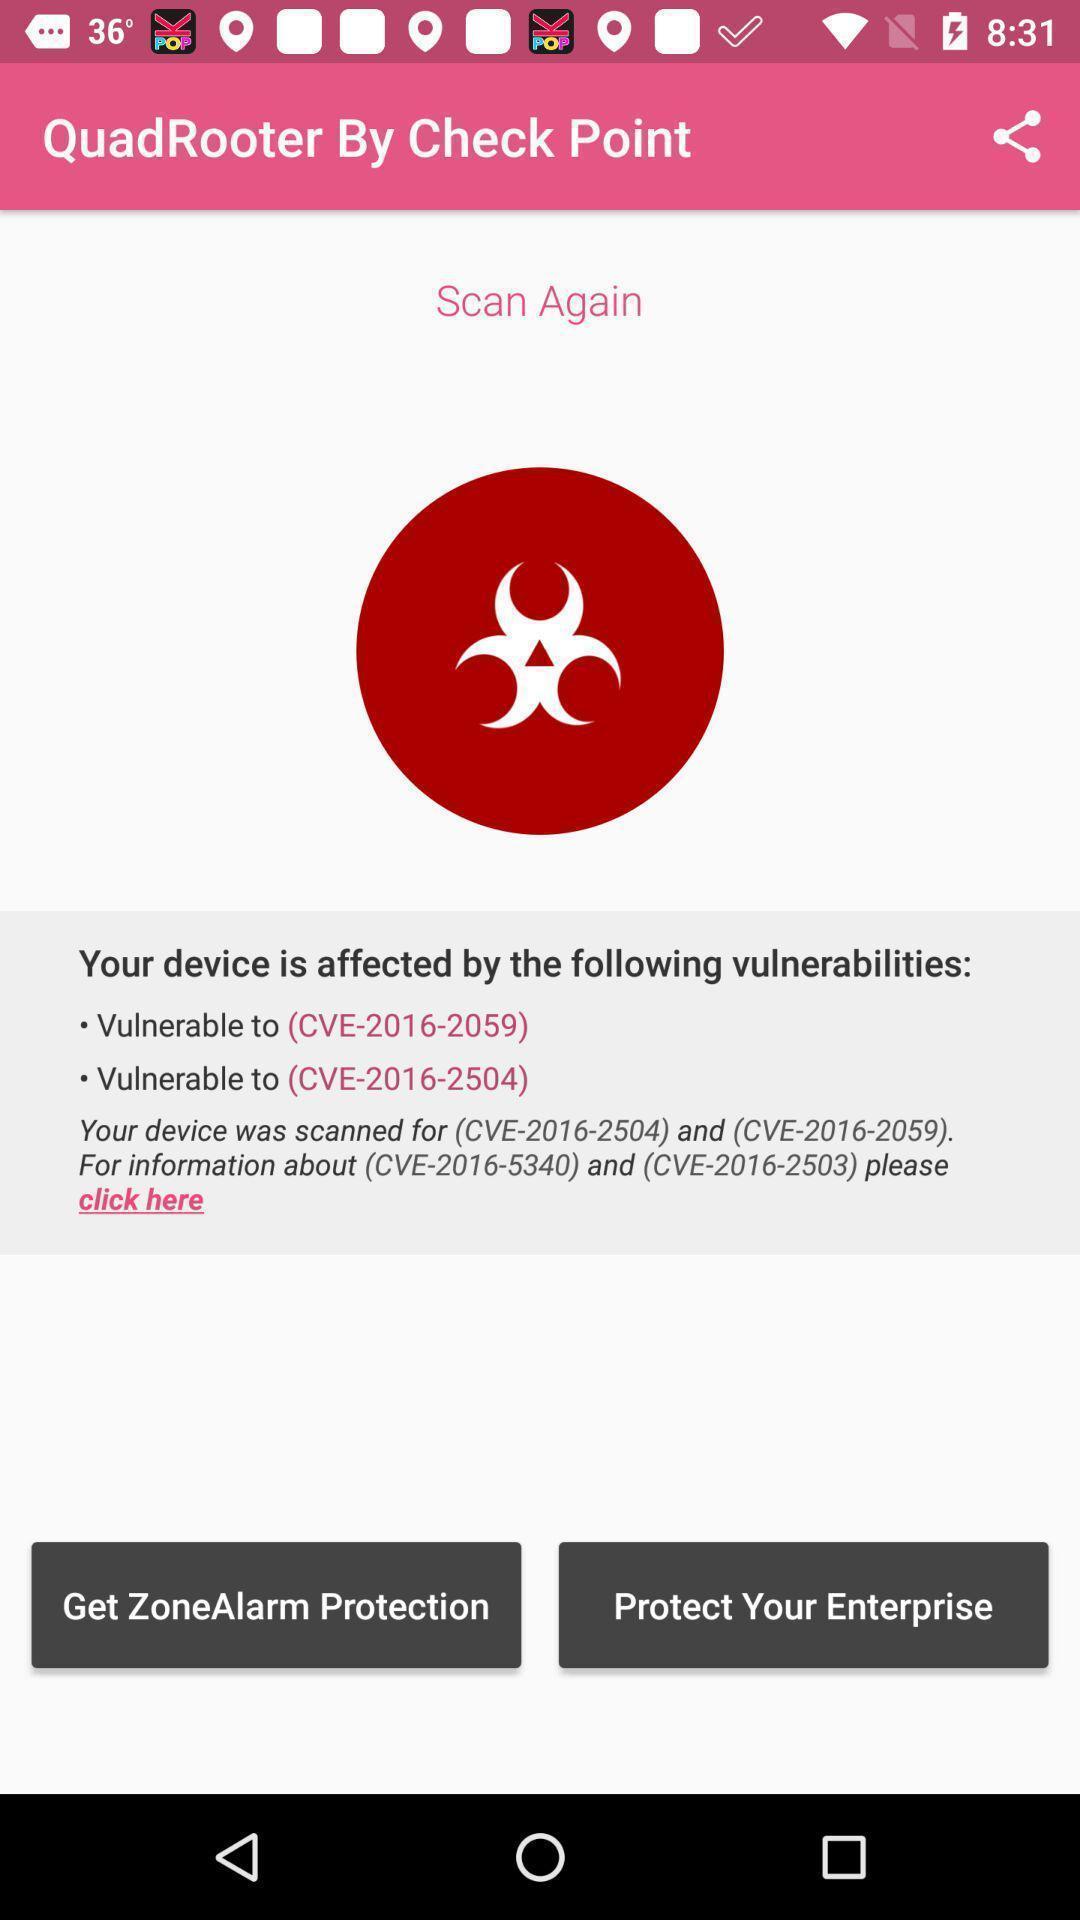Describe the key features of this screenshot. Screen shows a device on check point. 